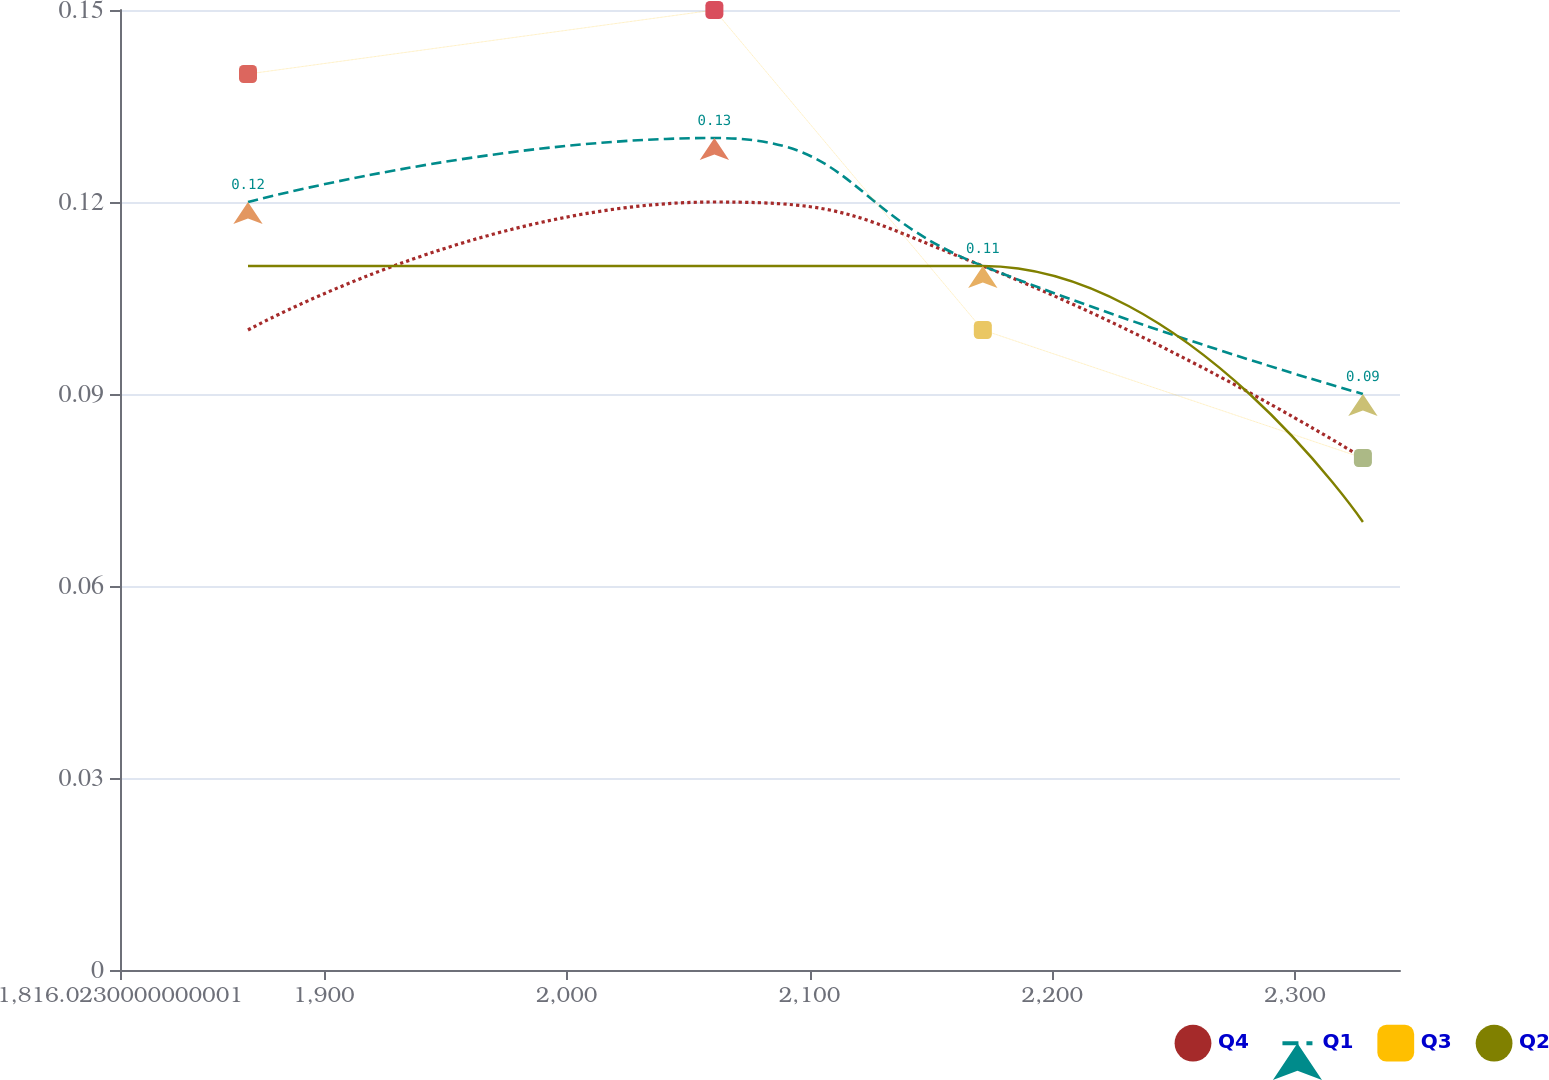<chart> <loc_0><loc_0><loc_500><loc_500><line_chart><ecel><fcel>Q4<fcel>Q1<fcel>Q3<fcel>Q2<nl><fcel>1868.74<fcel>0.1<fcel>0.12<fcel>0.14<fcel>0.11<nl><fcel>2060.82<fcel>0.12<fcel>0.13<fcel>0.15<fcel>0.11<nl><fcel>2171.38<fcel>0.11<fcel>0.11<fcel>0.1<fcel>0.11<nl><fcel>2327.92<fcel>0.08<fcel>0.09<fcel>0.08<fcel>0.07<nl><fcel>2395.91<fcel>0.06<fcel>0.07<fcel>0.05<fcel>0.07<nl></chart> 